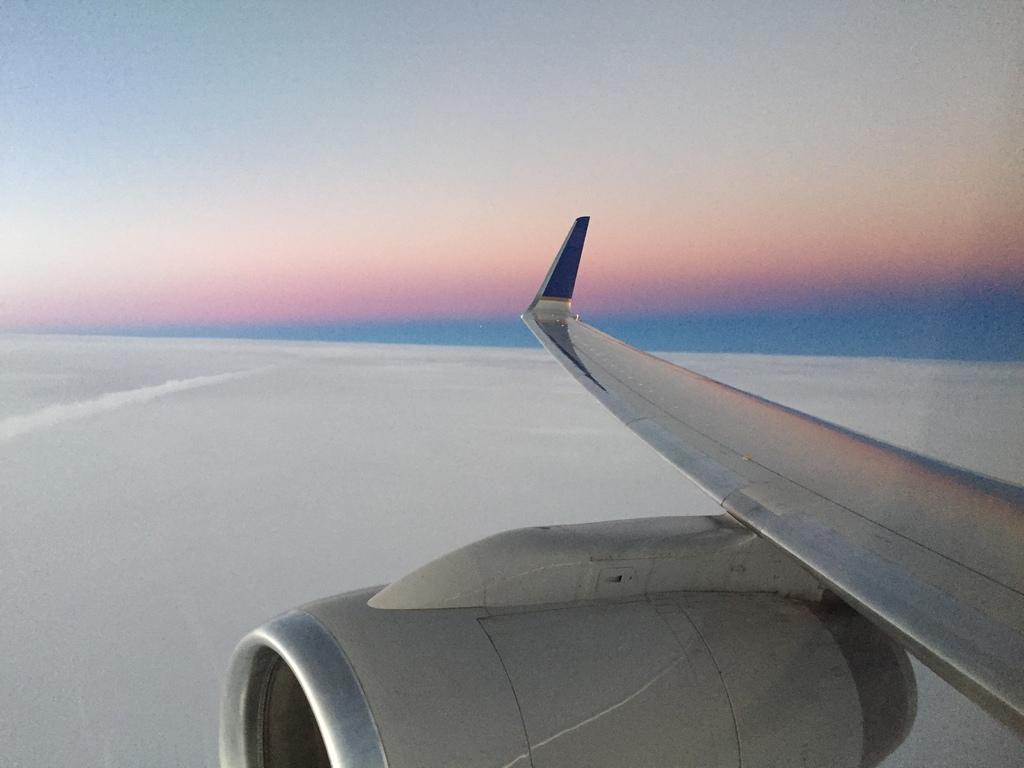What is the main subject of the image? The main subject of the image is an airplane. What is the airplane doing in the image? The airplane is flying in the sky. Where is the cannon located in the image? There is no cannon present in the image. What type of seed is being planted by the airplane in the image? There is no seed or planting activity depicted in the image; it features an airplane flying in the sky. 